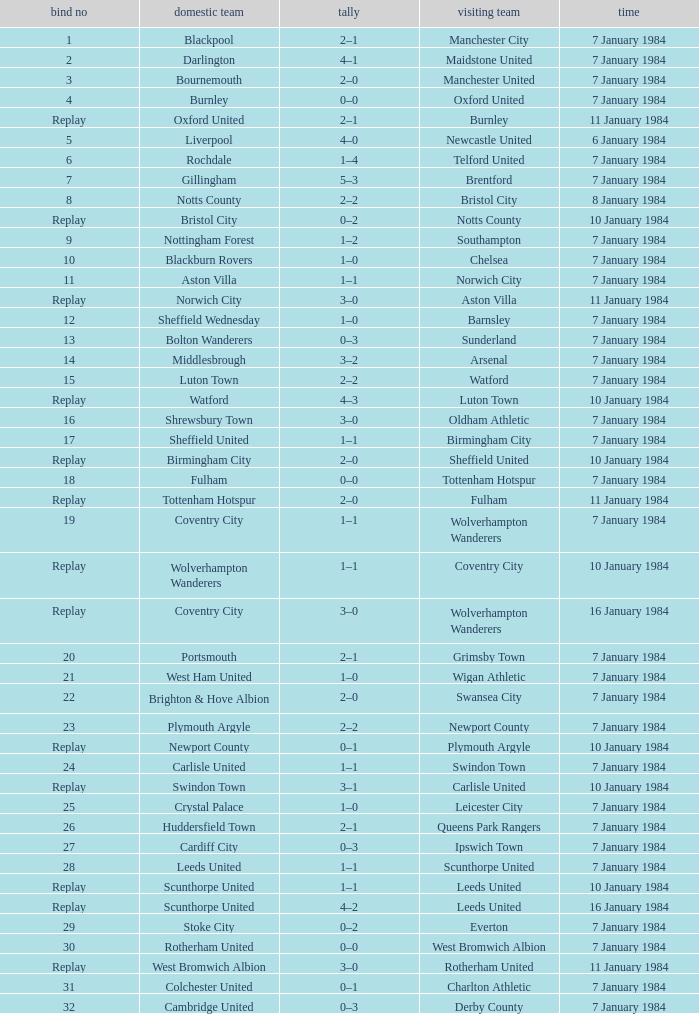Who was the away team with a tie of 14? Arsenal. 